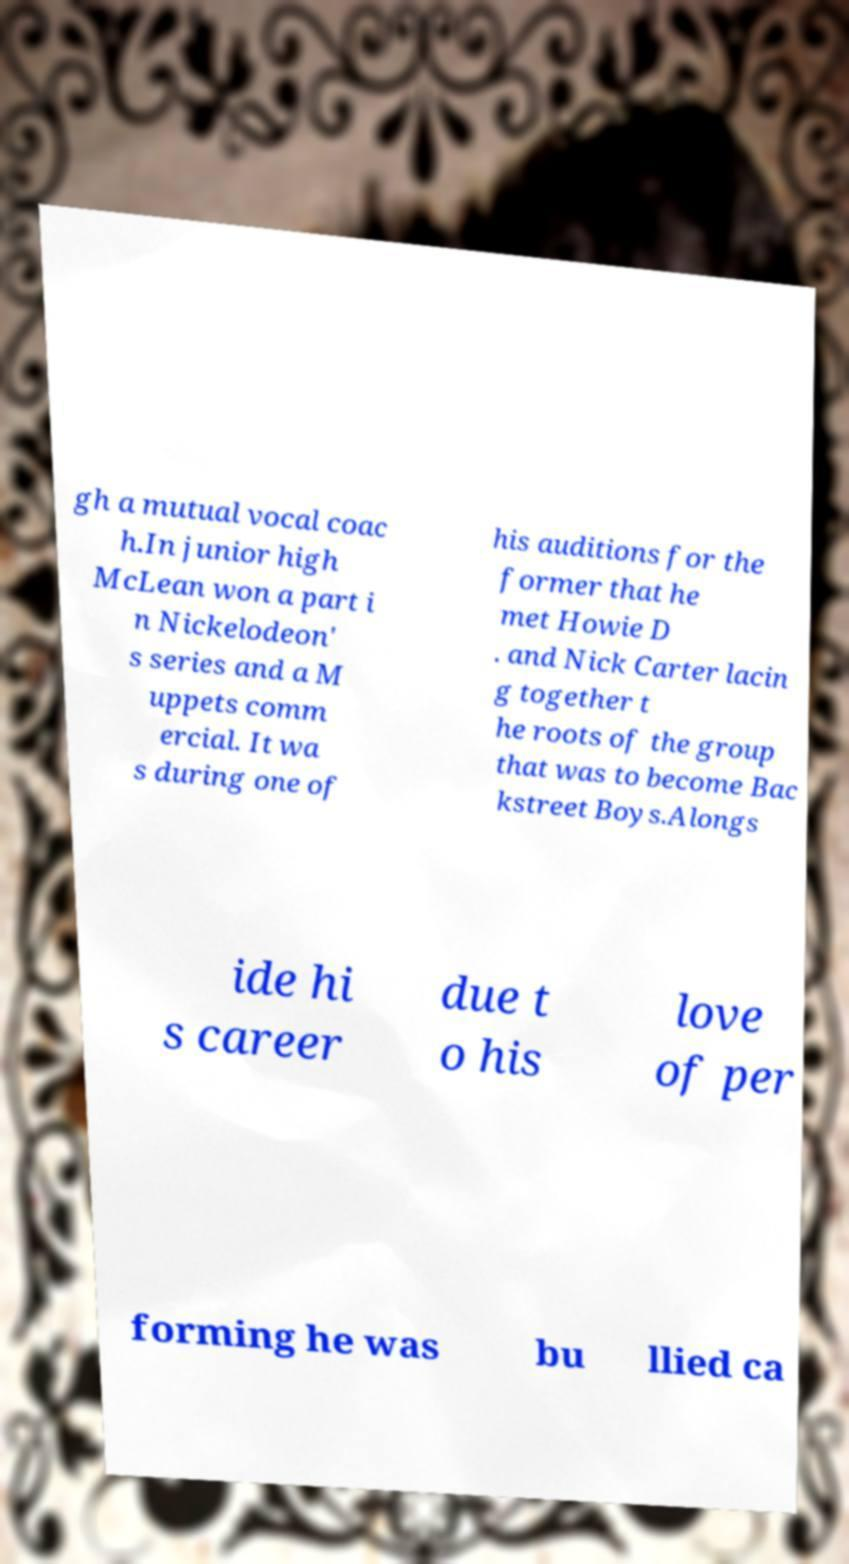For documentation purposes, I need the text within this image transcribed. Could you provide that? gh a mutual vocal coac h.In junior high McLean won a part i n Nickelodeon' s series and a M uppets comm ercial. It wa s during one of his auditions for the former that he met Howie D . and Nick Carter lacin g together t he roots of the group that was to become Bac kstreet Boys.Alongs ide hi s career due t o his love of per forming he was bu llied ca 